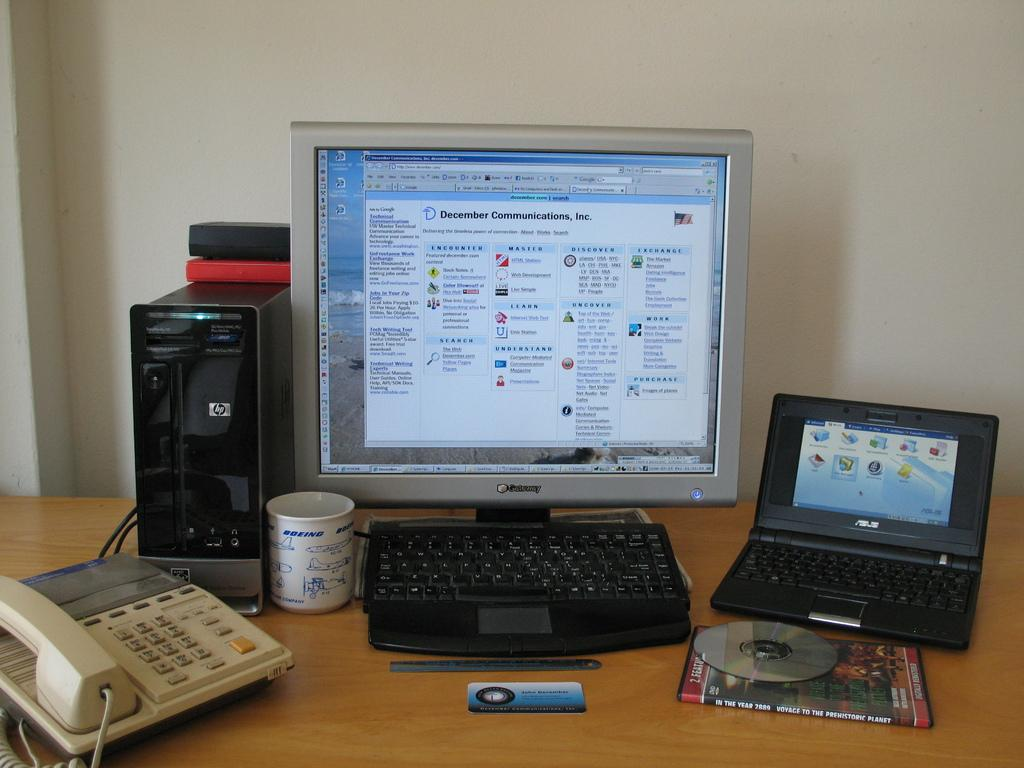What type of electronic device is visible in the image? There is a computer and a laptop in the image. What is used for input with the computer? There is a keyboard in the image. What type of storage medium can be seen in the image? There is a CD in the image. What type of reading material is present in the image? There is a book in the image. What type of communication device is visible in the image? There is a telephone in the image. What type of beverage container is present in the image? There is a cup in the image. What type of stationery item is visible in the image? There is a card in the image. What is the unspecified object on the table in the image? The unspecified object is not described in the facts provided. What type of sweater is the person wearing in the image? There is no person or sweater present in the image. What type of scene is depicted in the image? The image does not depict a scene; it shows various objects on a table. 